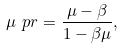<formula> <loc_0><loc_0><loc_500><loc_500>\mu \ p r = \frac { \mu - \beta } { 1 - \beta \mu } ,</formula> 